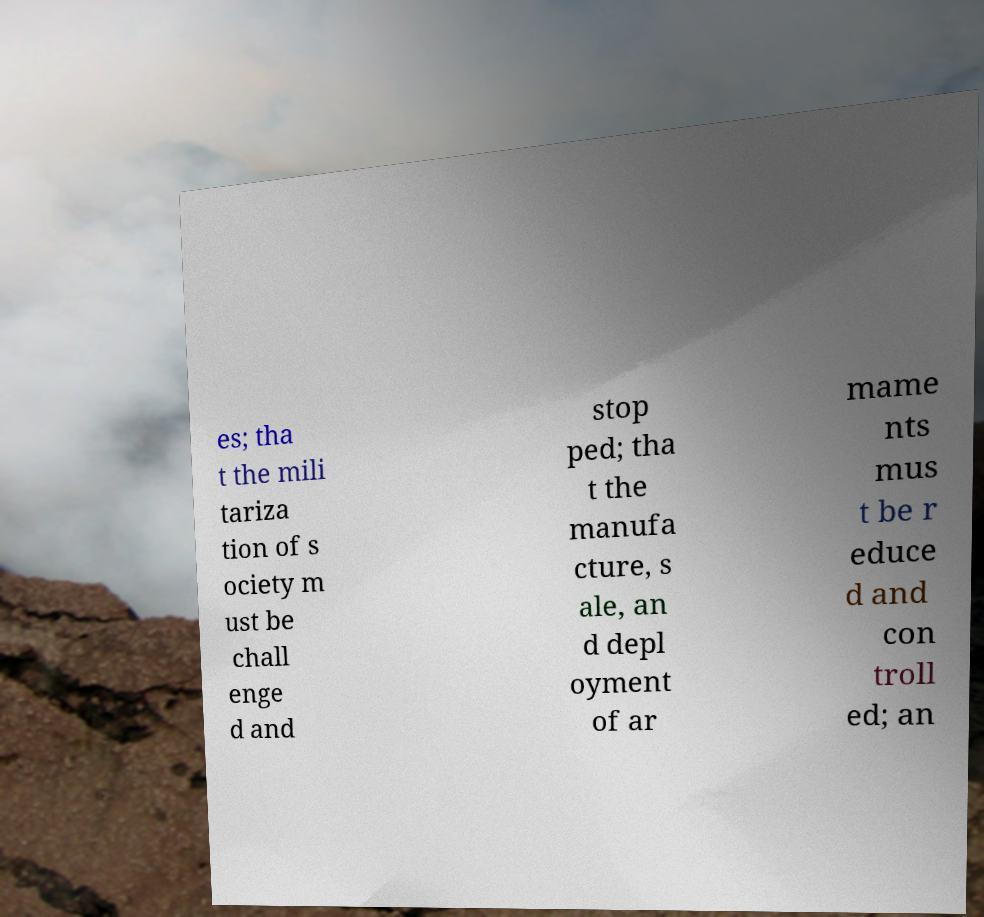Please identify and transcribe the text found in this image. es; tha t the mili tariza tion of s ociety m ust be chall enge d and stop ped; tha t the manufa cture, s ale, an d depl oyment of ar mame nts mus t be r educe d and con troll ed; an 